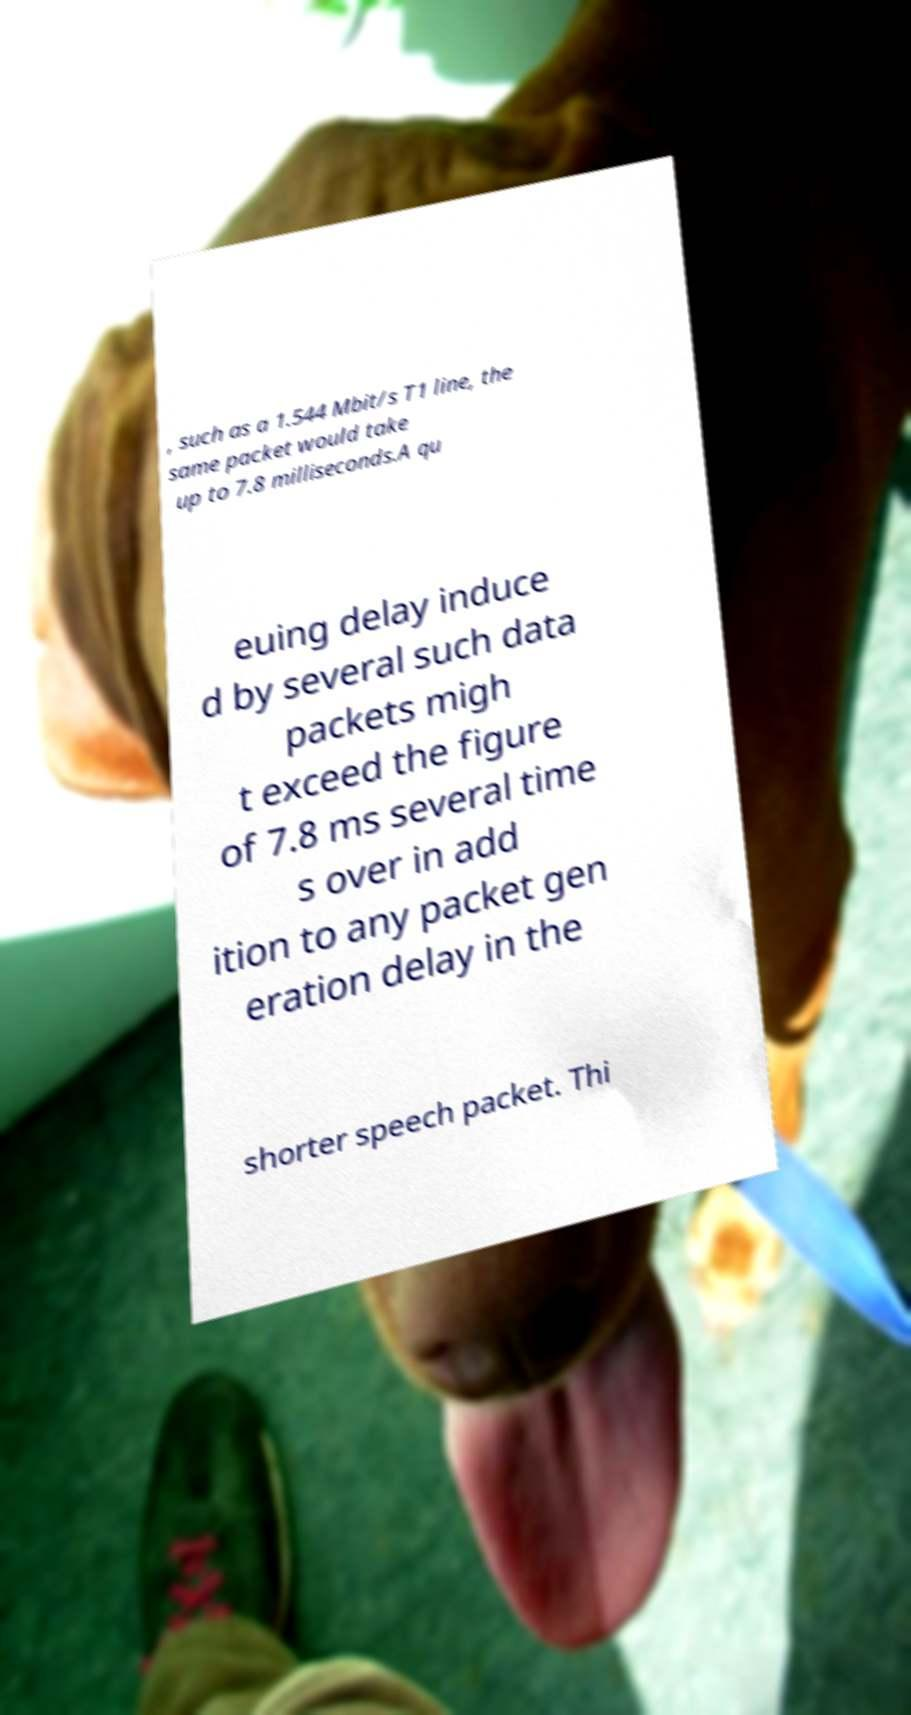What messages or text are displayed in this image? I need them in a readable, typed format. , such as a 1.544 Mbit/s T1 line, the same packet would take up to 7.8 milliseconds.A qu euing delay induce d by several such data packets migh t exceed the figure of 7.8 ms several time s over in add ition to any packet gen eration delay in the shorter speech packet. Thi 